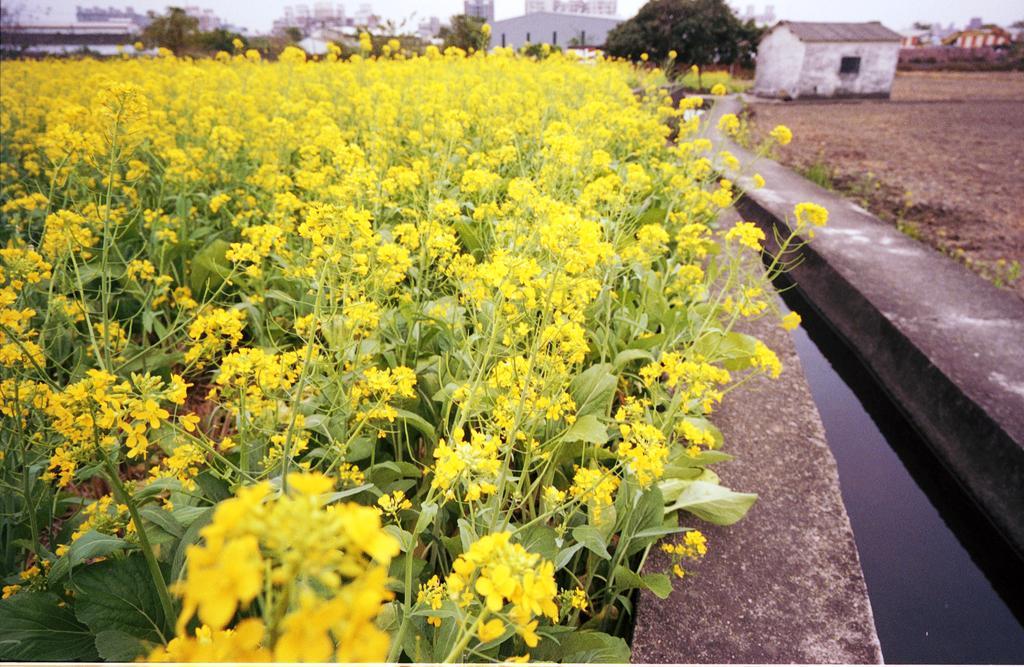Please provide a concise description of this image. Background portion of the picture is blurry and we can see the buildings and houses. In this picture we can see the flower plants and flowers are in yellow color. On the right side of the picture we can see the groundwater and the walls. 